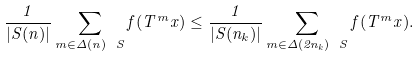Convert formula to latex. <formula><loc_0><loc_0><loc_500><loc_500>\frac { 1 } { | S ( n ) | } \sum _ { m \in \Delta ( n ) \ S } f ( T ^ { m } x ) \leq \frac { 1 } { | S ( n _ { k } ) | } \sum _ { m \in \Delta ( 2 n _ { k } ) \ S } f ( T ^ { m } x ) .</formula> 